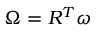Convert formula to latex. <formula><loc_0><loc_0><loc_500><loc_500>{ \boldsymbol \Omega } = R ^ { T } { \boldsymbol \omega }</formula> 